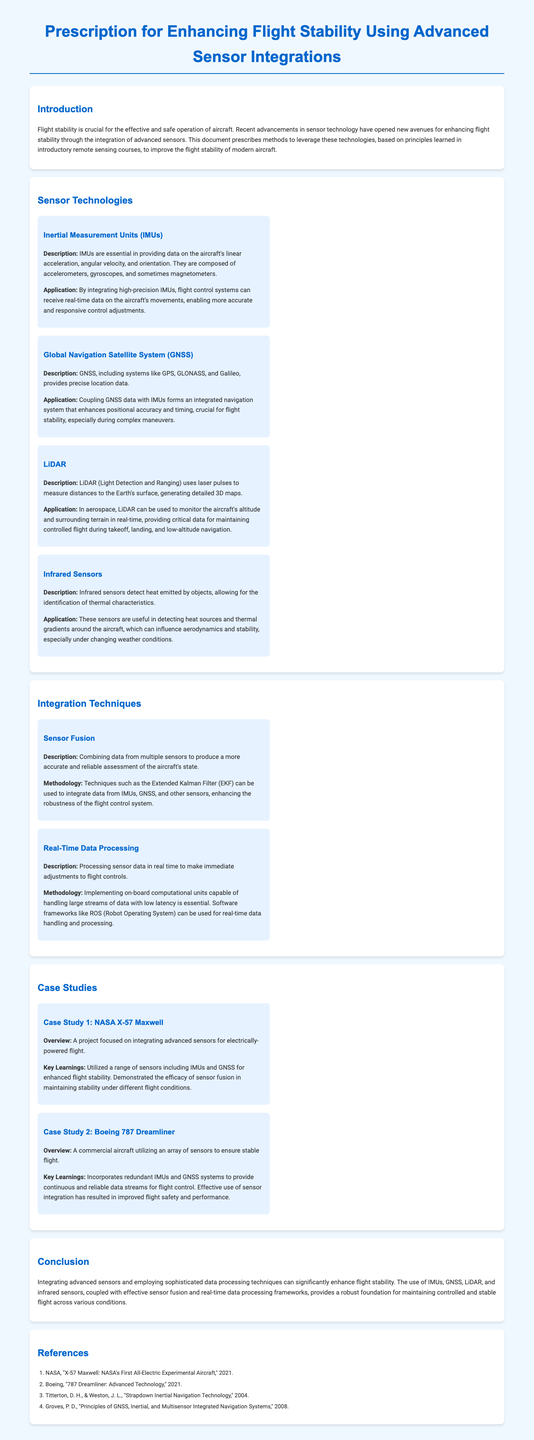what is the title of the document? The title of the document is found in the header section, summarizing its purpose and focus.
Answer: Prescription for Enhancing Flight Stability Using Advanced Sensor Integrations how many case studies are presented? The document lists two specific case studies under the Case Studies section.
Answer: 2 what sensor technology is essential for providing data on linear acceleration? The document indicates that Inertial Measurement Units (IMUs) are composed of various sensors, crucial for this purpose.
Answer: Inertial Measurement Units (IMUs) which integration technique uses the Extended Kalman Filter? The document mentions that Sensor Fusion is the methodology that employs the Extended Kalman Filter for integrating sensor data.
Answer: Sensor Fusion what does LiDAR stand for? The document explains that LiDAR stands for Light Detection and Ranging, describing its functionality briefly.
Answer: Light Detection and Ranging what is the primary learning from the NASA X-57 Maxwell case study? The case study outlines that the project demonstrated the efficacy of sensor fusion for stability under varying conditions.
Answer: Efficacy of sensor fusion which system combines GNSS with IMUs for enhanced navigation? The document states that coupling GNSS data with IMUs enhances positional accuracy for navigation systems.
Answer: Integrated navigation system what year were the Boeing 787 Dreamliner technologies discussed? The references in the document indicate that it refers to information from the year 2021.
Answer: 2021 